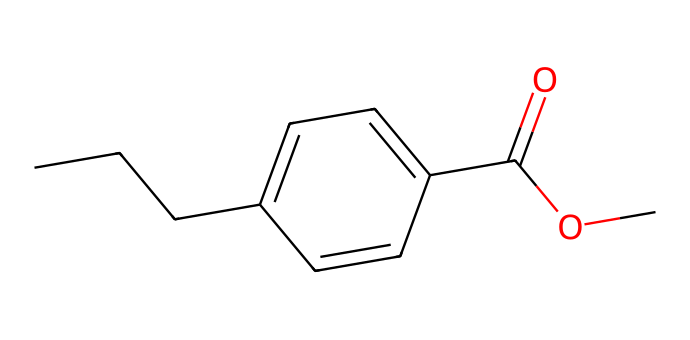What is the molecular formula of this chemical? By analyzing the structure represented by the SMILES, we can count the number of each type of atom present: 10 carbon atoms, 12 hydrogen atoms, and 2 oxygen atoms. Thus, the molecular formula becomes C10H12O2.
Answer: C10H12O2 How many rings are present in the structure? The SMILES indicates a cyclic structure where there is one ring described (looking for the 'C1' and 'C' that closes the cycle). Thus, there is one ring present in the structure.
Answer: 1 What type of functional group is indicated by the "=O" in the structure? The "=O" specifies a carbonyl group (C=O), which is characteristic of esters and other similar compounds. In this case, it is part of an ester because it is adjacent to an ether link (C-O).
Answer: carbonyl How many double bonds are present in the chemical structure? Upon examining the SMILES representation, we note there is one double bond in the ring, and one additional double bond in the carbonyl group, resulting in a total of two double bonds present in the structure.
Answer: 2 What is the primary role of propylparaben in lubricants? Propylparaben functions as a preservative, preventing the growth of bacteria and mold, thus prolonging the shelf-life and integrity of the lubricant.
Answer: preservative Which type of chemical is propylparaben classified as? Propylparaben is classified as a paraben, which is a type of preservative used widely in cosmetics and personal care products, including lubricants.
Answer: paraben 